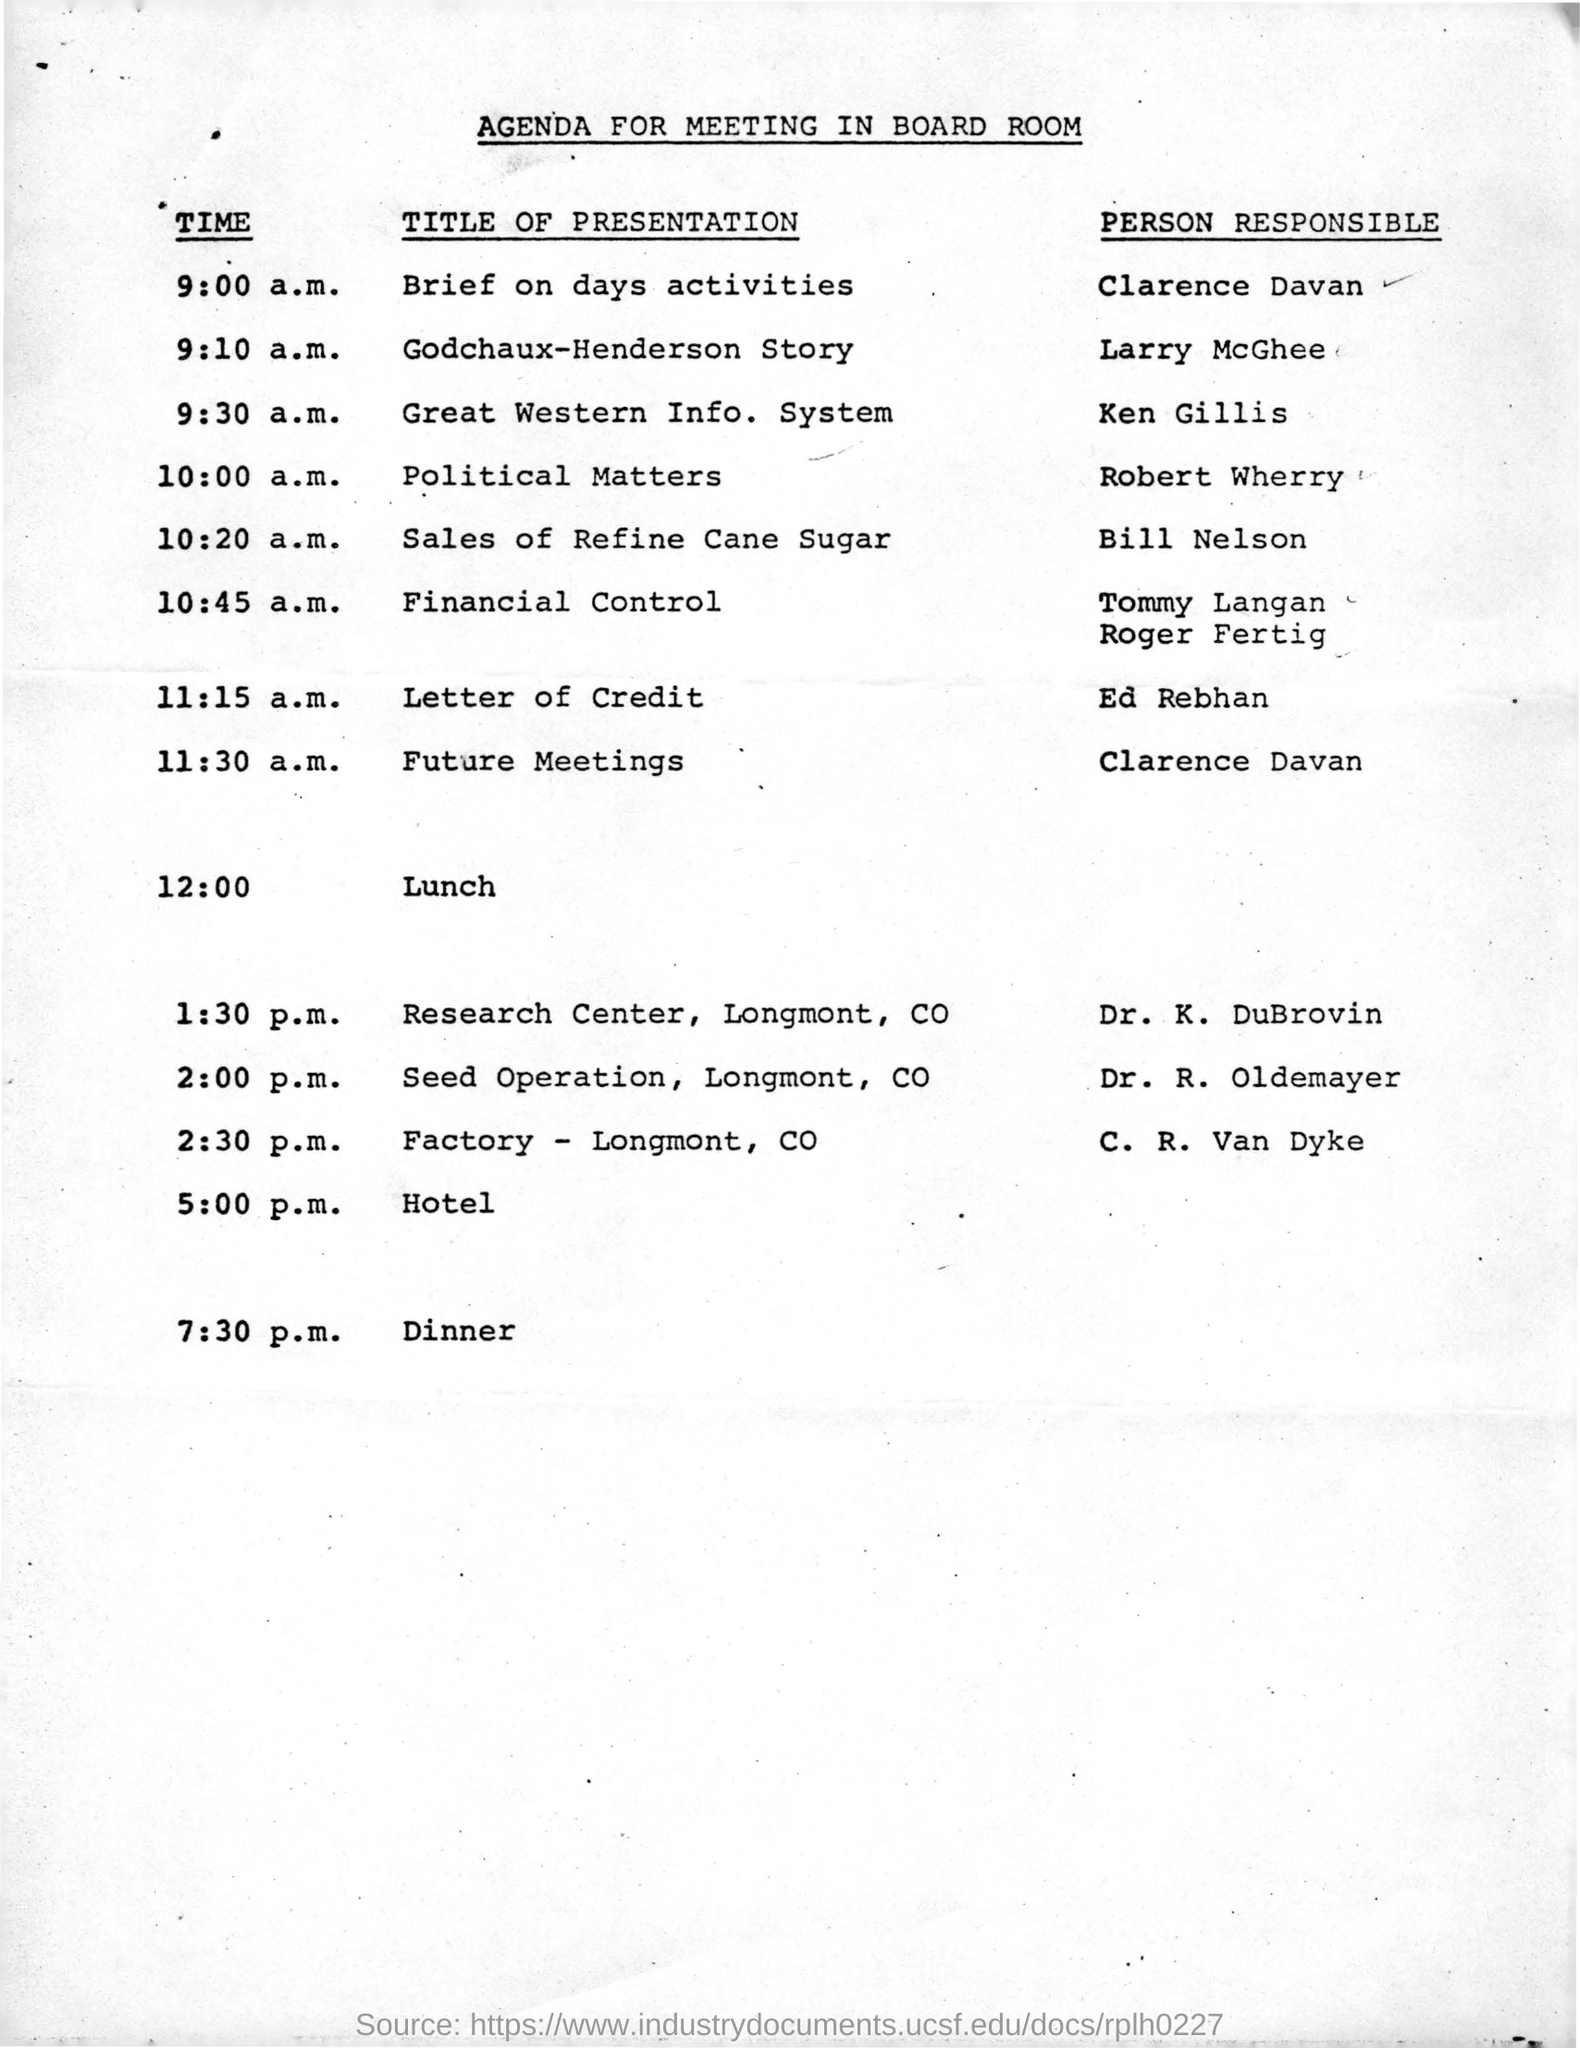Where is the meeting held?
Give a very brief answer. BOARD ROOM. What is Larry McGhee presenting?
Give a very brief answer. Godchaux-Henderson Story. Who is presenting Political Matters?
Your answer should be very brief. ROBERT WHERRY. Whose presentation is the first after lunch?
Keep it short and to the point. Dr. K. Dubrovin. At what time is Ken Gillis's presentation?
Give a very brief answer. 9:30 A.M. Who presents brief of the activities for the day?
Keep it short and to the point. Clarence Davan. 